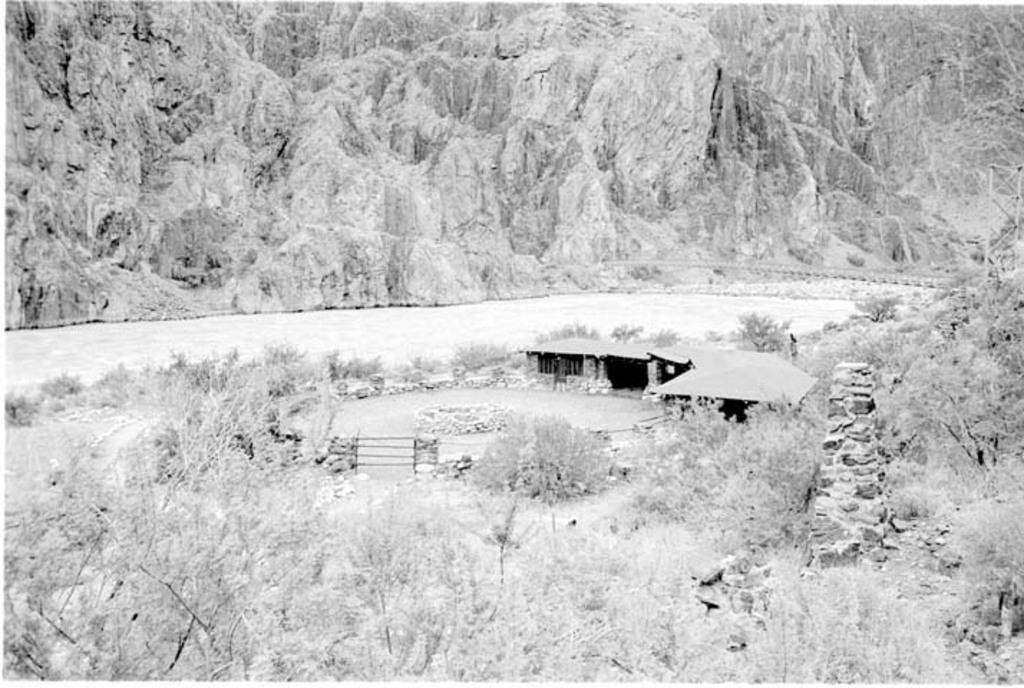What type of landscape is depicted in the image? The image features hills, trees, and water, suggesting a natural landscape. What structures can be seen in the image? There are sheds visible in the image. What type of vegetation is present in the image? There are trees and plants in the image. Can you describe the water in the image? The water is visible in the image, but its specific characteristics are not mentioned in the facts. What type of company is conducting a class near the water in the image? There is no company or class present in the image; it features a natural landscape with hills, trees, sheds, water, and plants. 